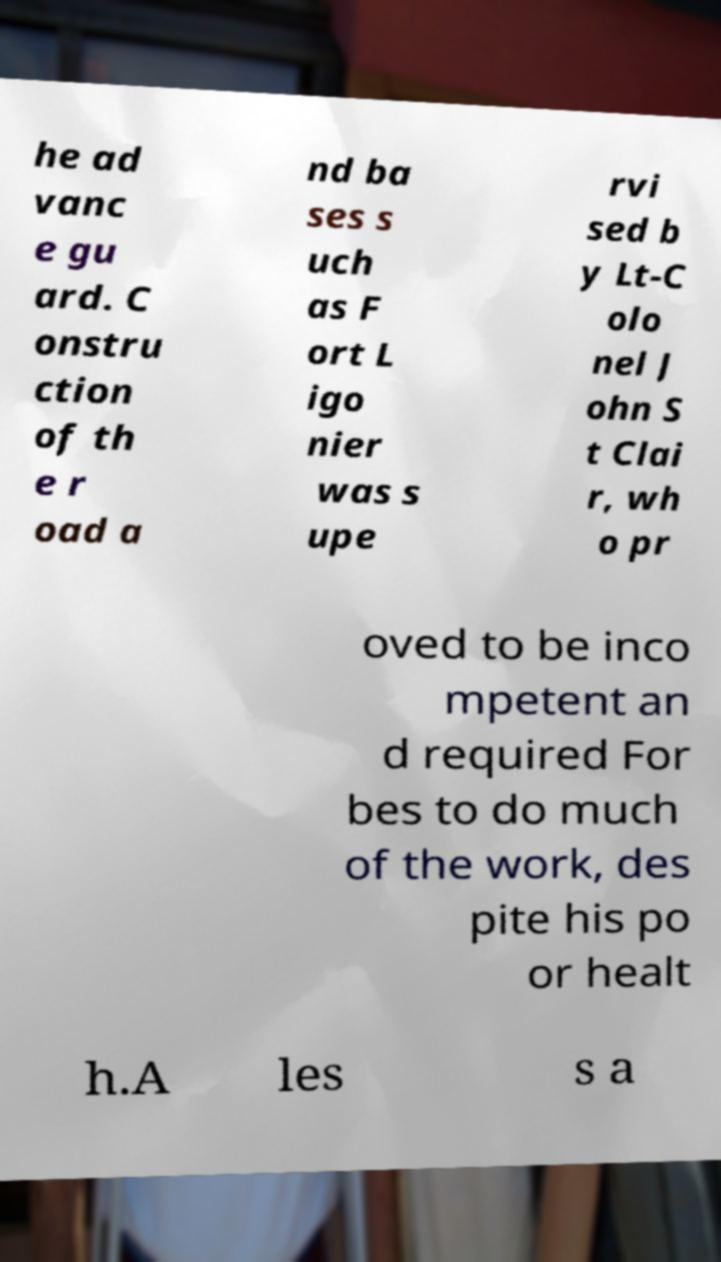I need the written content from this picture converted into text. Can you do that? he ad vanc e gu ard. C onstru ction of th e r oad a nd ba ses s uch as F ort L igo nier was s upe rvi sed b y Lt-C olo nel J ohn S t Clai r, wh o pr oved to be inco mpetent an d required For bes to do much of the work, des pite his po or healt h.A les s a 